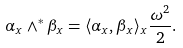<formula> <loc_0><loc_0><loc_500><loc_500>\alpha _ { x } \wedge ^ { * } \beta _ { x } = \langle \alpha _ { x } , \beta _ { x } \rangle _ { x } \frac { \omega ^ { 2 } } { 2 } .</formula> 